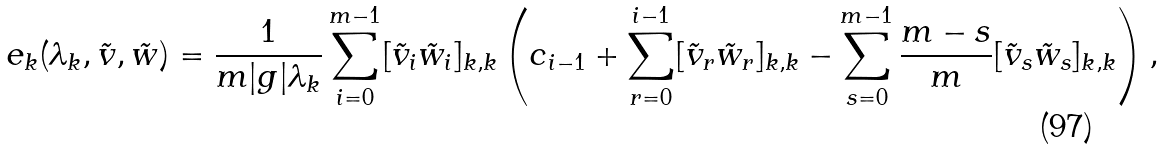<formula> <loc_0><loc_0><loc_500><loc_500>e _ { k } ( \lambda _ { k } , \tilde { v } , \tilde { w } ) = \frac { 1 } { m | g | \lambda _ { k } } \sum _ { i = 0 } ^ { m - 1 } [ \tilde { v } _ { i } \tilde { w } _ { i } ] _ { k , k } \left ( c _ { i - 1 } + \sum _ { r = 0 } ^ { i - 1 } [ \tilde { v } _ { r } \tilde { w } _ { r } ] _ { k , k } - \sum _ { s = 0 } ^ { m - 1 } \frac { m - s } { m } [ \tilde { v } _ { s } \tilde { w } _ { s } ] _ { k , k } \right ) ,</formula> 